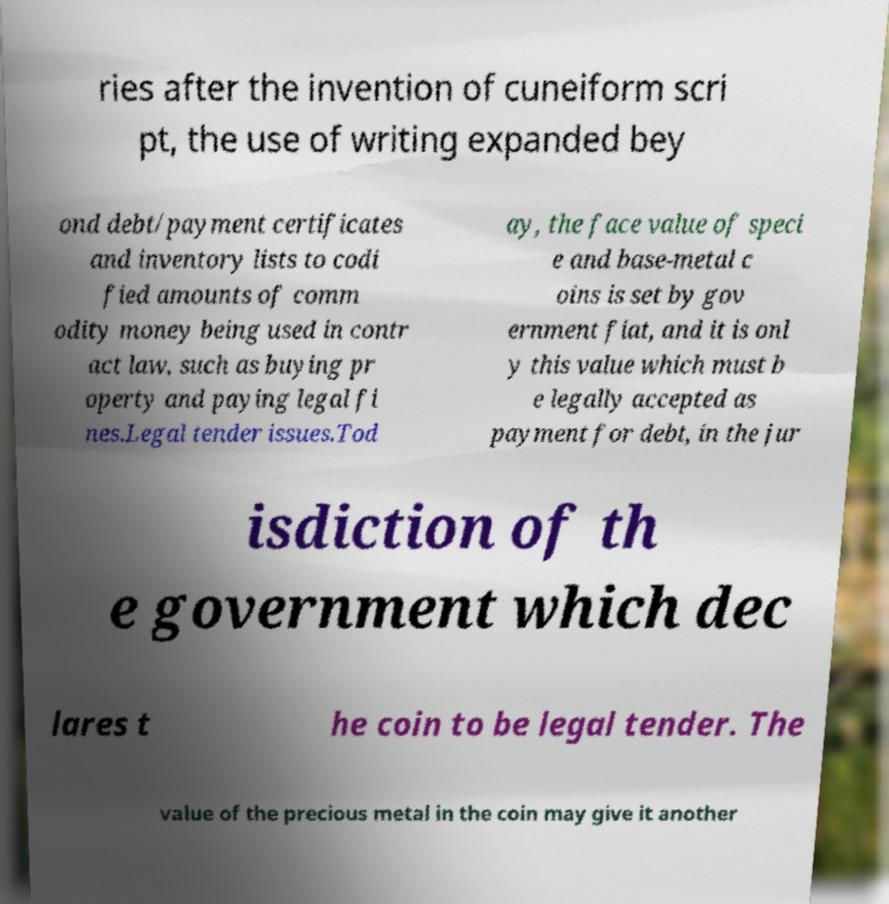Can you accurately transcribe the text from the provided image for me? ries after the invention of cuneiform scri pt, the use of writing expanded bey ond debt/payment certificates and inventory lists to codi fied amounts of comm odity money being used in contr act law, such as buying pr operty and paying legal fi nes.Legal tender issues.Tod ay, the face value of speci e and base-metal c oins is set by gov ernment fiat, and it is onl y this value which must b e legally accepted as payment for debt, in the jur isdiction of th e government which dec lares t he coin to be legal tender. The value of the precious metal in the coin may give it another 